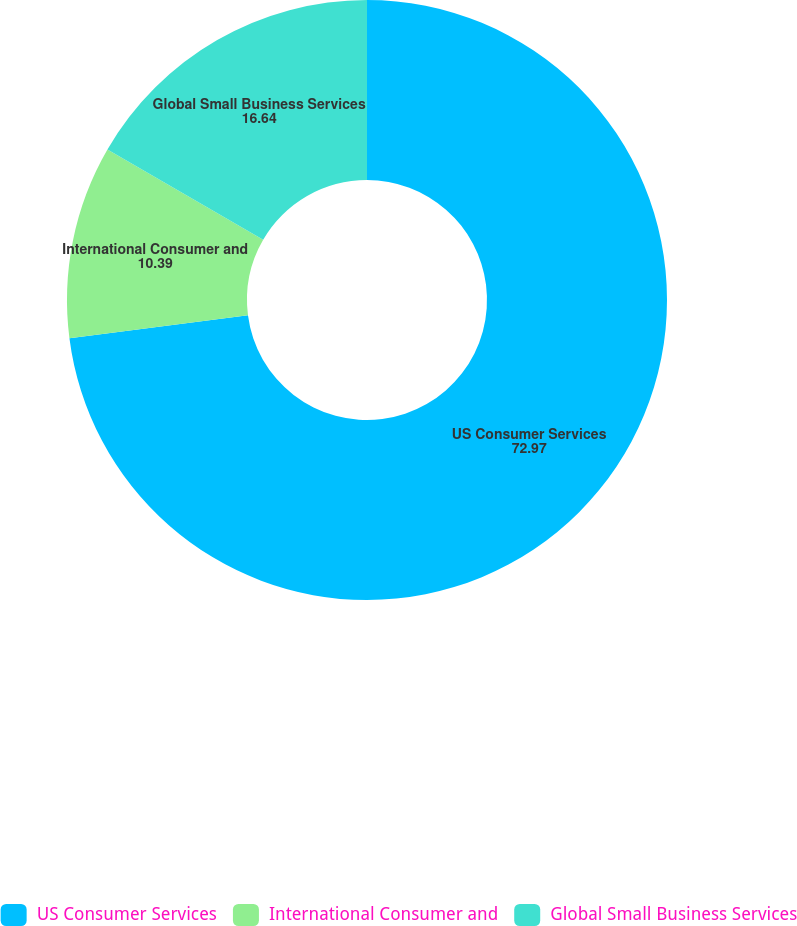Convert chart. <chart><loc_0><loc_0><loc_500><loc_500><pie_chart><fcel>US Consumer Services<fcel>International Consumer and<fcel>Global Small Business Services<nl><fcel>72.97%<fcel>10.39%<fcel>16.64%<nl></chart> 